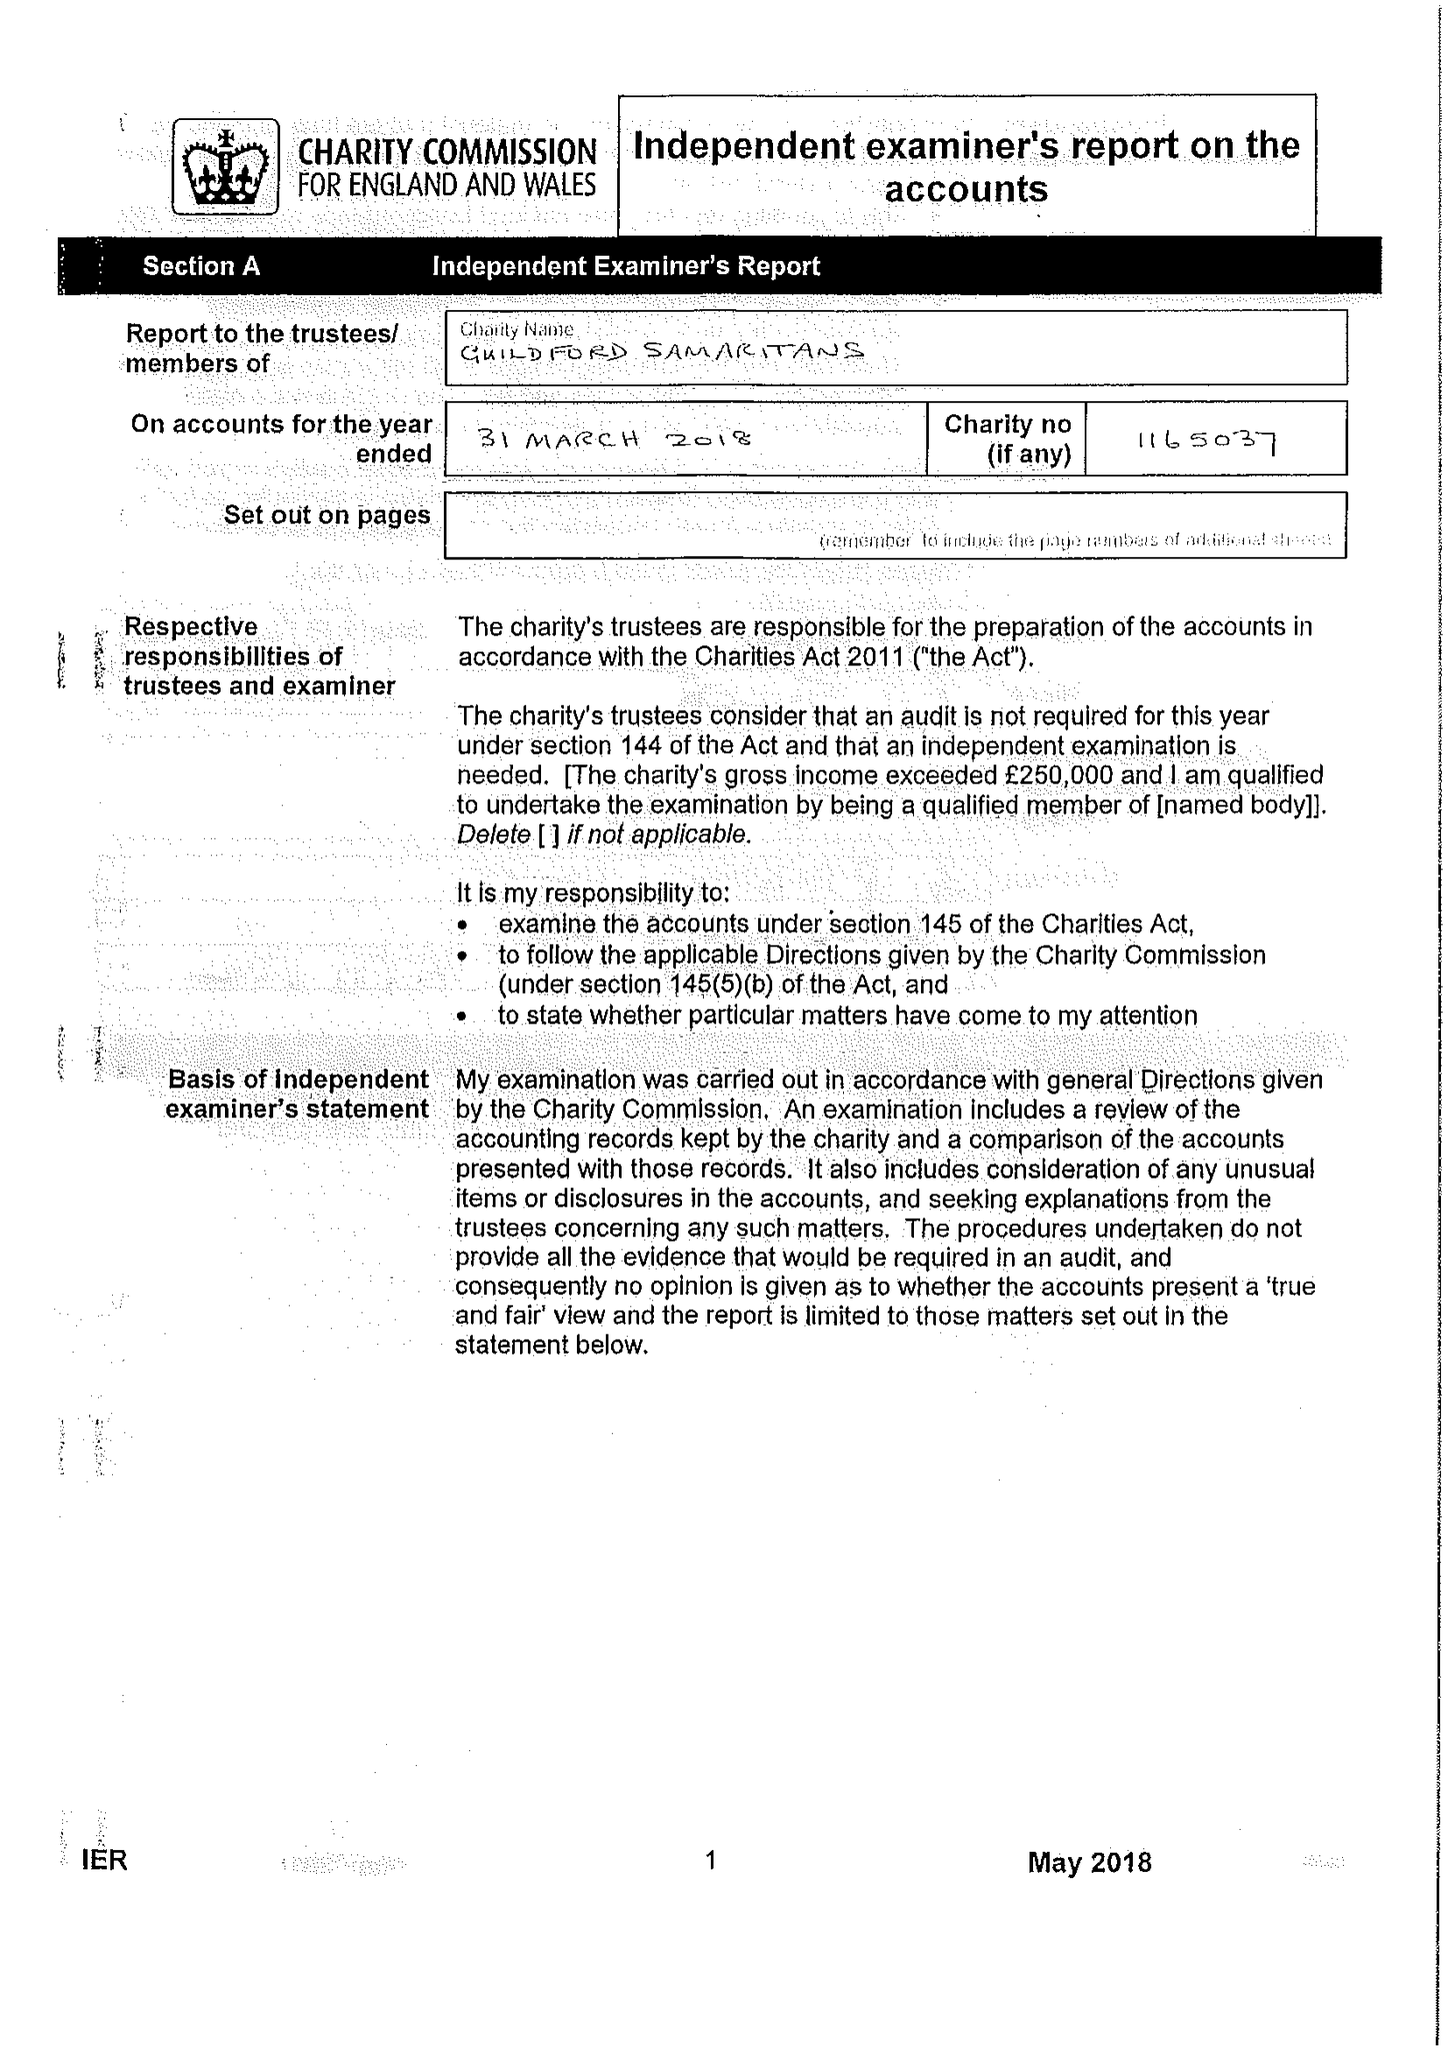What is the value for the address__street_line?
Answer the question using a single word or phrase. 69 WOODBRIDGE ROAD 